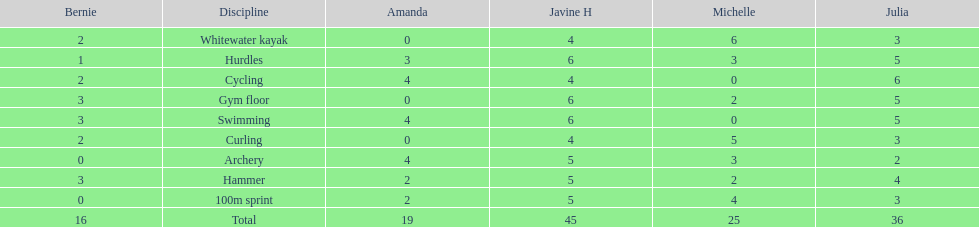What other girl besides amanda also had a 4 in cycling? Javine H. 